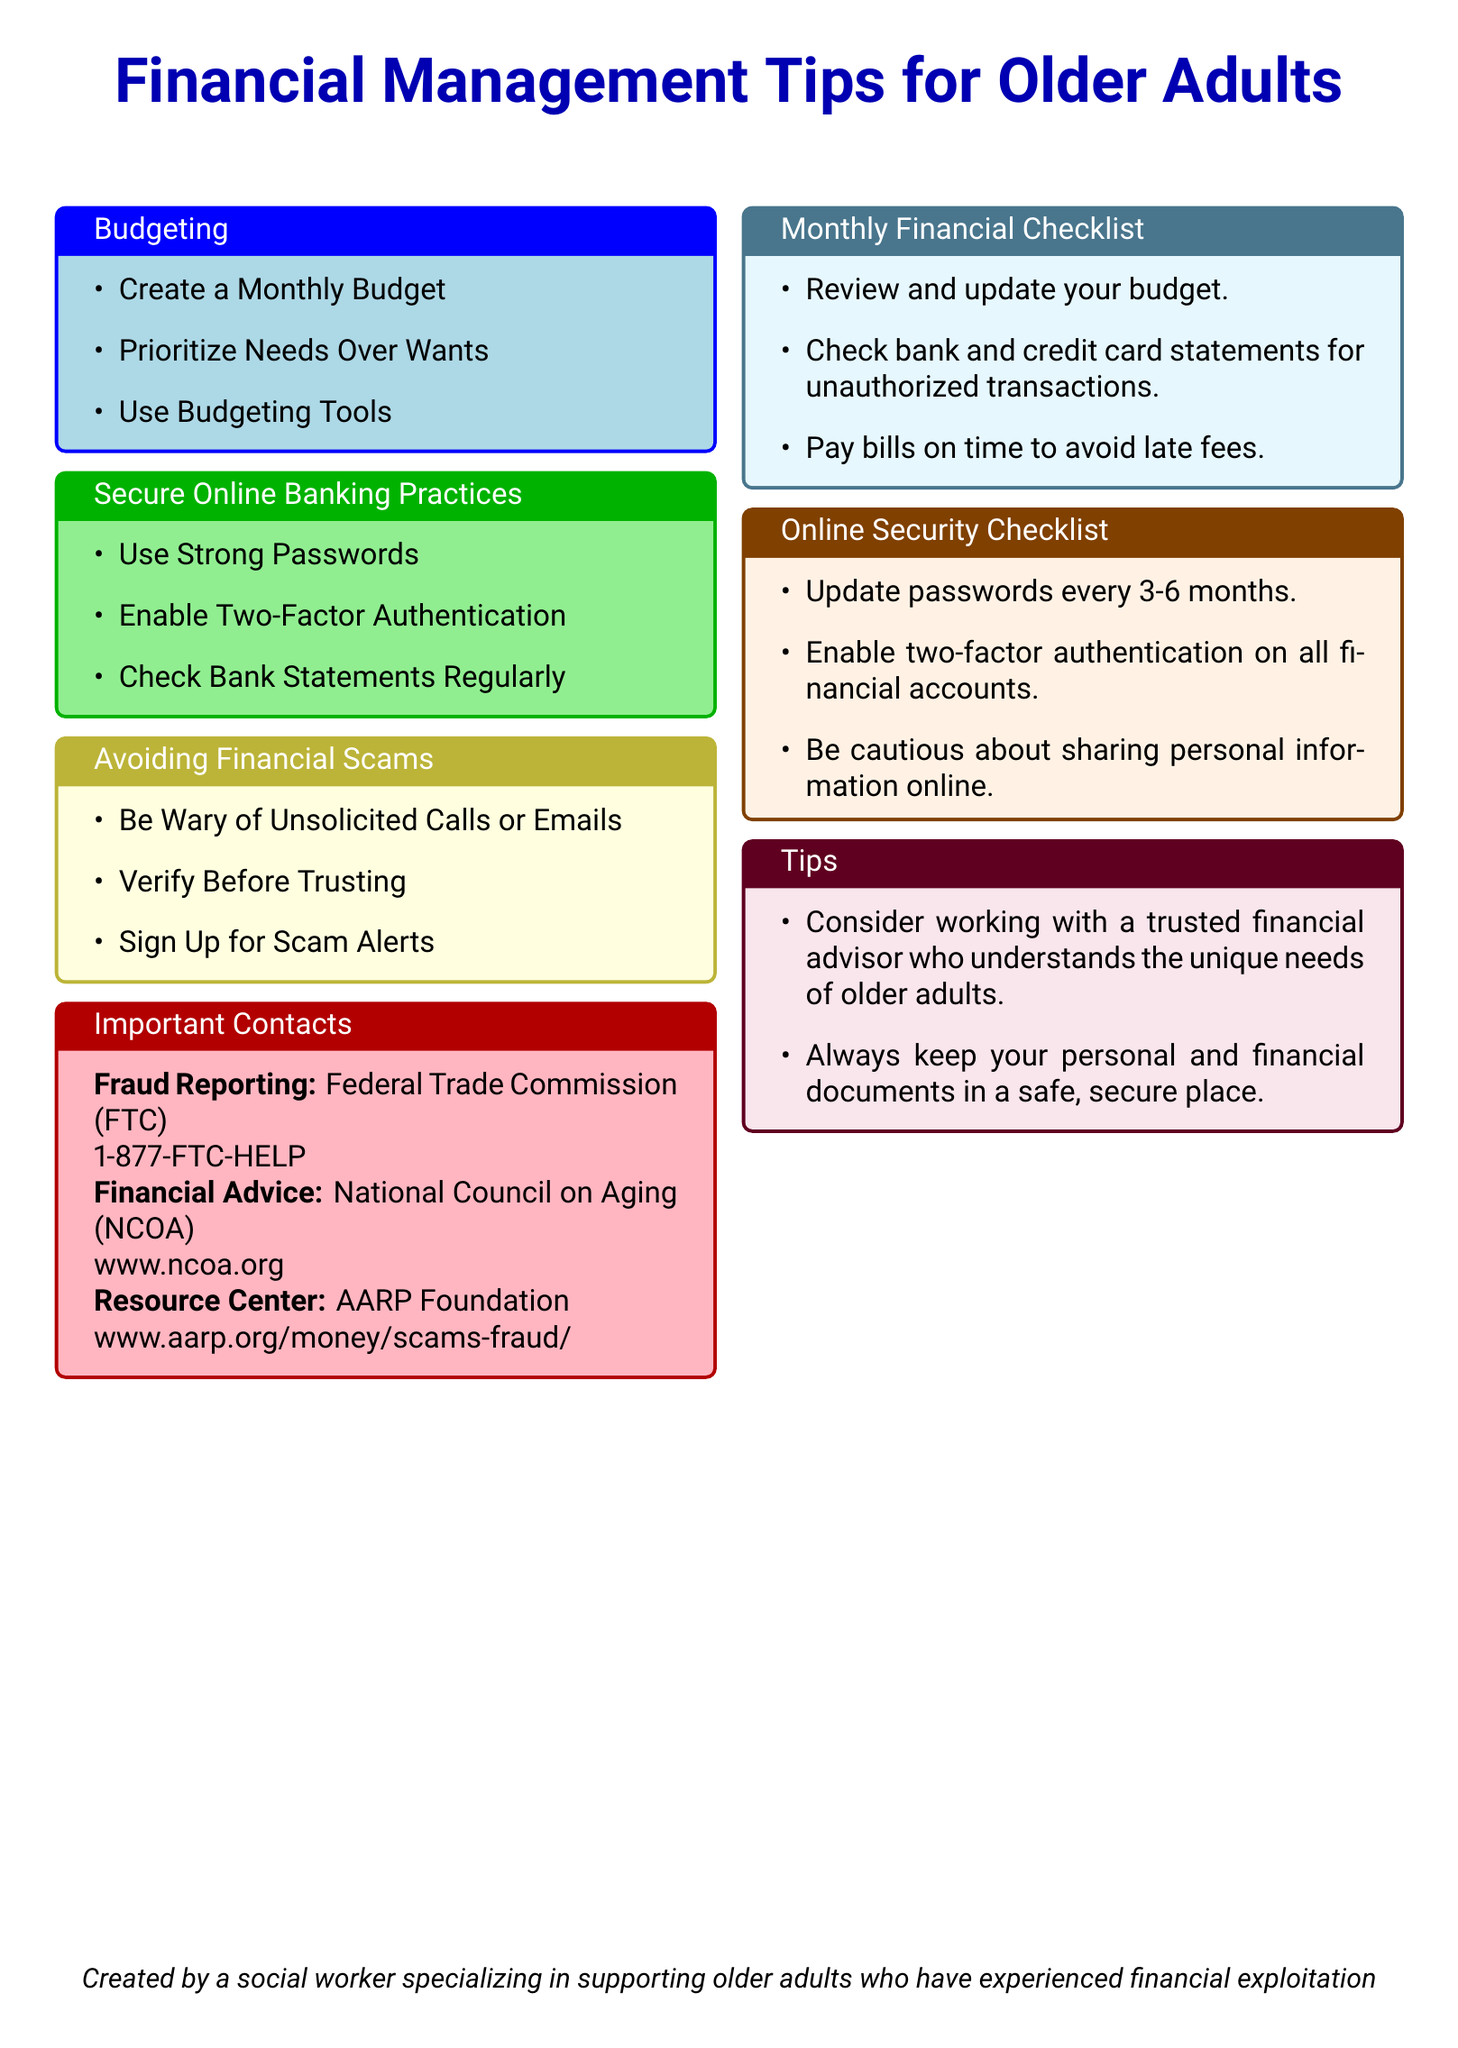What is the title of the flyer? The title is prominently displayed at the beginning of the document, labeled in large font.
Answer: Financial Management Tips for Older Adults What are two topics covered in the budgeting section? The budgeting section lists specific practices that can help manage finances effectively.
Answer: Create a Monthly Budget, Prioritize Needs Over Wants What is one secure online banking practice suggested? This practice is among the recommendations to enhance online banking security.
Answer: Use Strong Passwords What should you do if you receive unsolicited calls or emails? This is a guideline provided to help avoid financial scams.
Answer: Be Wary of Unsolicited Calls or Emails What is the contact number for the Federal Trade Commission? This number is provided for reporting fraud and is specified in the important contacts section.
Answer: 1-877-FTC-HELP How frequently should you update your passwords? This is mentioned as a best practice for online security.
Answer: Every 3-6 months What is one tip offered for older adults in financial management? This tip is provided to encourage a proactive approach to financial well-being.
Answer: Consider working with a trusted financial advisor What color is the section that highlights online security checklist? The color distinction helps to make the category visually identifiable.
Answer: Orange What organization is associated with the resource center for scams and fraud? This organization's name is listed in the important contacts for financial advice.
Answer: AARP Foundation 